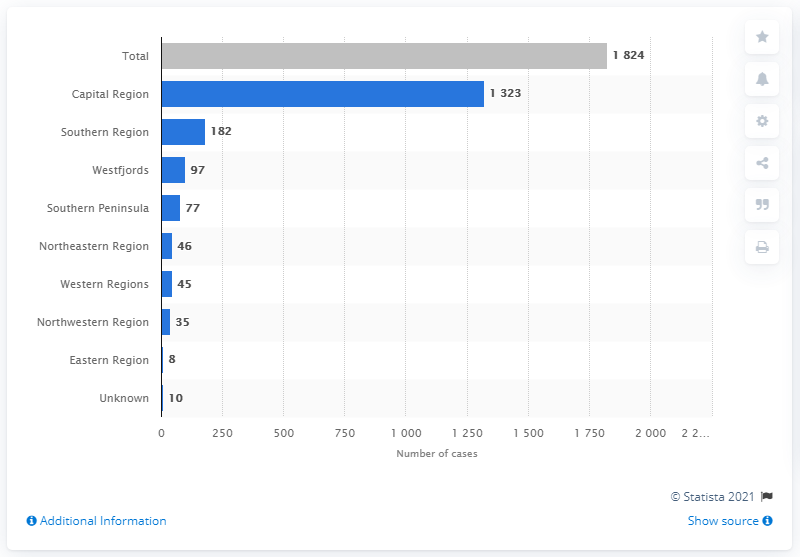List a handful of essential elements in this visual. The Capital Region had the highest number of confirmed cases of COVID-19 in Iceland as of June 11, 2020. In the Southern Region, a total of 182 cases have been confirmed. 